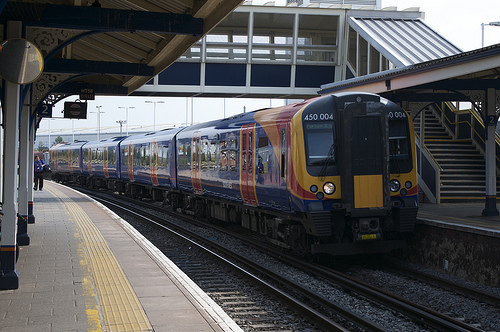Please provide the bounding box coordinate of the region this sentence describes: Stairs are in the background. Stairs in the background are visible within the coordinates [0.81, 0.37, 0.98, 0.57], providing access to different levels of the station for both passengers and staff, enhancing the station's functionality. 